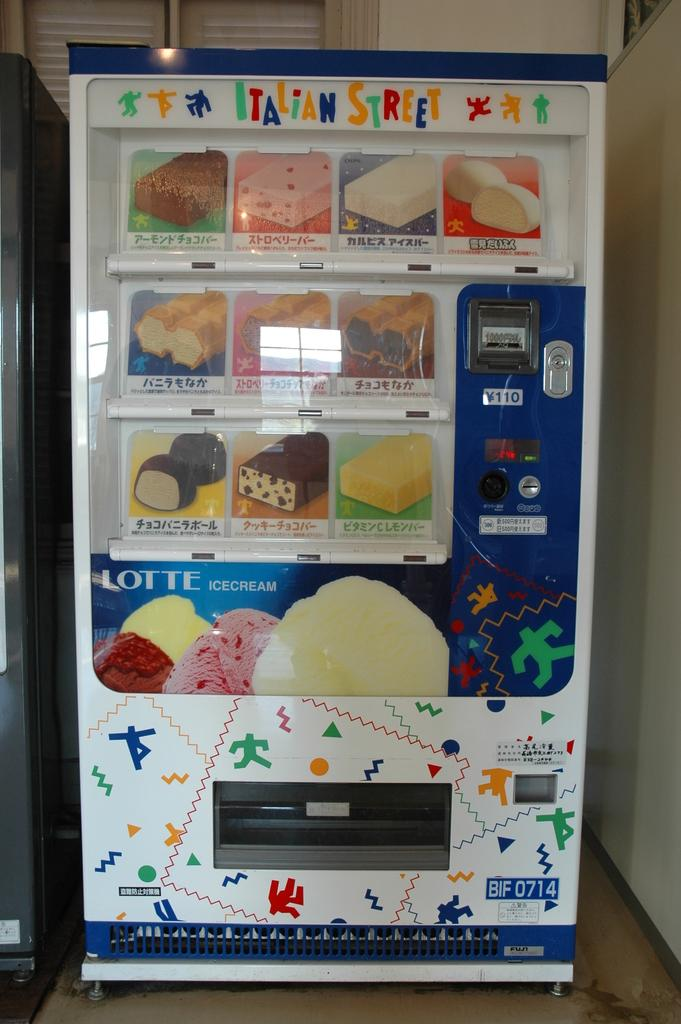<image>
Share a concise interpretation of the image provided. A vending machine that sells ice cream called Italian Street 